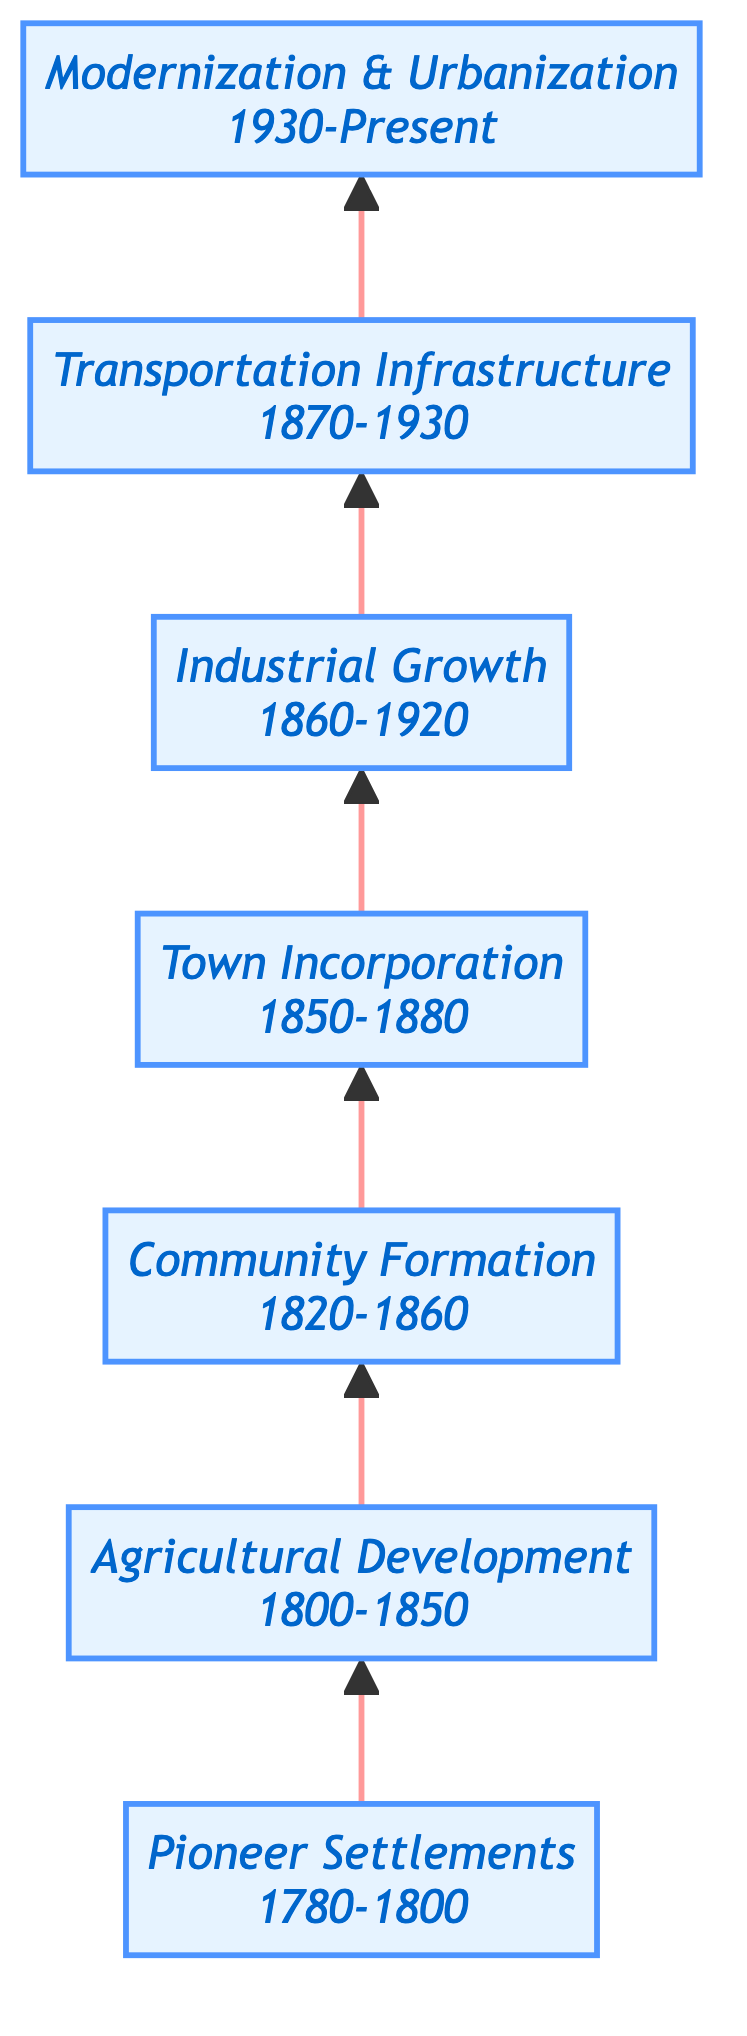What is the starting point of the development depicted in the diagram? The diagram begins with "Pioneer Settlements," which represents the initial settlements established by early pioneers like the Chapman and Vance families.
Answer: Pioneer Settlements How many major developmental phases are illustrated in the diagram? The diagram contains seven major phases of development, starting from Pioneer Settlements and ending with Modernization & Urbanization.
Answer: 7 What year range is associated with Town Incorporation? The year range that corresponds to Town Incorporation as shown in the diagram is from 1850 to 1880.
Answer: 1850-1880 Which phase comes directly after Community Formation? Following Community Formation in the diagram is the Town Incorporation phase, indicating the transition from community structures to official town status.
Answer: Town Incorporation What significant development occurred between 1870 and 1930? Between 1870 and 1930, the diagram indicates the establishment of Transportation Infrastructure, facilitating trade and mobility in the area.
Answer: Transportation Infrastructure What is the primary focus of the phase labeled Modernization & Urbanization? The phase of Modernization & Urbanization focuses on the continued urbanization, introduction of modern amenities, and growth of the population leading to the towns of today.
Answer: Continued urbanization Explain the relationship between Industrial Growth and Transportation Infrastructure. Industrial Growth, which spans from 1860 to 1920, leads into the Transportation Infrastructure phase from 1870 to 1930. This indicates that as industries developed, transportation systems were established to support them, enhancing trade and mobility.
Answer: Industrial Growth leads to Transportation Infrastructure What was the focus of development from 1800 to 1850? The period from 1800 to 1850 is primarily focused on Agricultural Development, which emphasizes the expansion of farmlands and agricultural innovations.
Answer: Agricultural Development In what years did Community Formation occur? Community Formation took place from 1820 to 1860, showcasing a period of building community structures such as schools and churches.
Answer: 1820-1860 